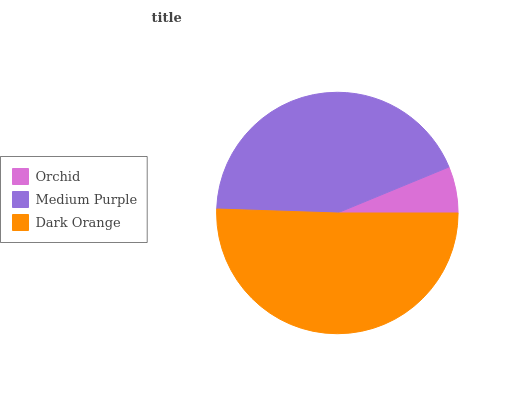Is Orchid the minimum?
Answer yes or no. Yes. Is Dark Orange the maximum?
Answer yes or no. Yes. Is Medium Purple the minimum?
Answer yes or no. No. Is Medium Purple the maximum?
Answer yes or no. No. Is Medium Purple greater than Orchid?
Answer yes or no. Yes. Is Orchid less than Medium Purple?
Answer yes or no. Yes. Is Orchid greater than Medium Purple?
Answer yes or no. No. Is Medium Purple less than Orchid?
Answer yes or no. No. Is Medium Purple the high median?
Answer yes or no. Yes. Is Medium Purple the low median?
Answer yes or no. Yes. Is Orchid the high median?
Answer yes or no. No. Is Orchid the low median?
Answer yes or no. No. 